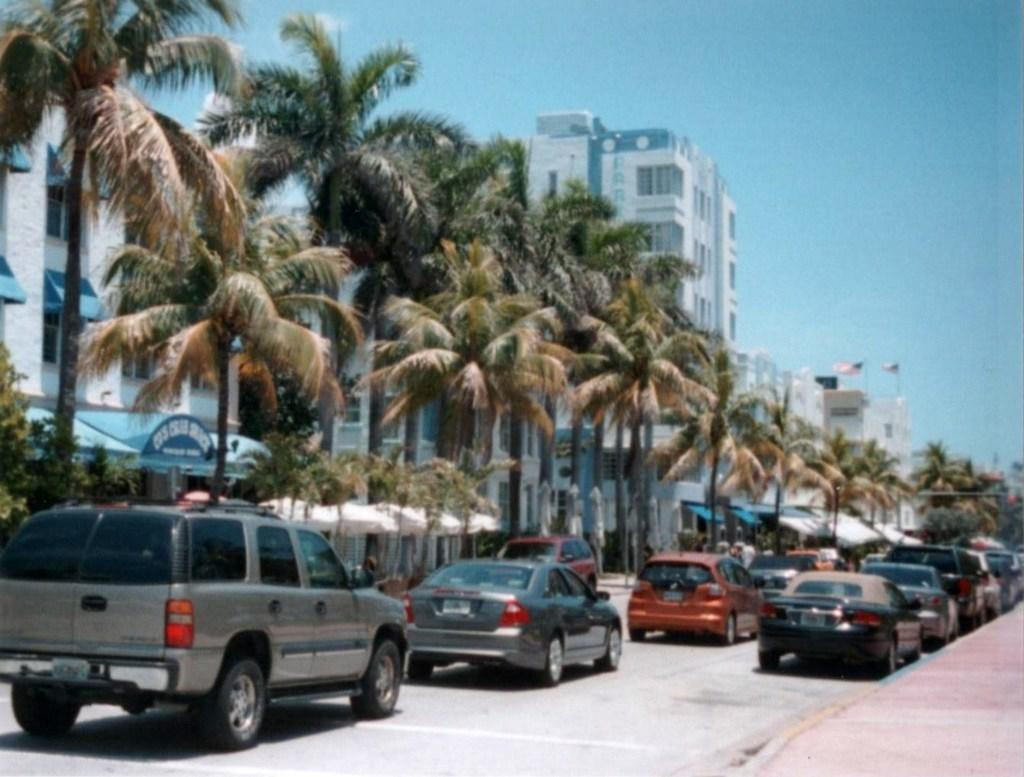What can be seen on the road in the image? There are vehicles on the road in the image. What is located next to the road in the image? There is a sidewalk in the image. What is on the left side of the image? There are trees and buildings on the left side of the image. What objects are present in the image that might be used for protection from the elements? There are umbrellas in the image. What objects are present in the image that represent a country or organization? There are flags in the image. What part of the natural environment is visible in the image? The sky is visible in the image. How many houses are visible in the image? There is no mention of houses in the provided facts, so we cannot determine the number of houses in the image. Are there any fairies visible in the image? There is no mention of fairies in the provided facts, so we cannot determine if any are present in the image. 